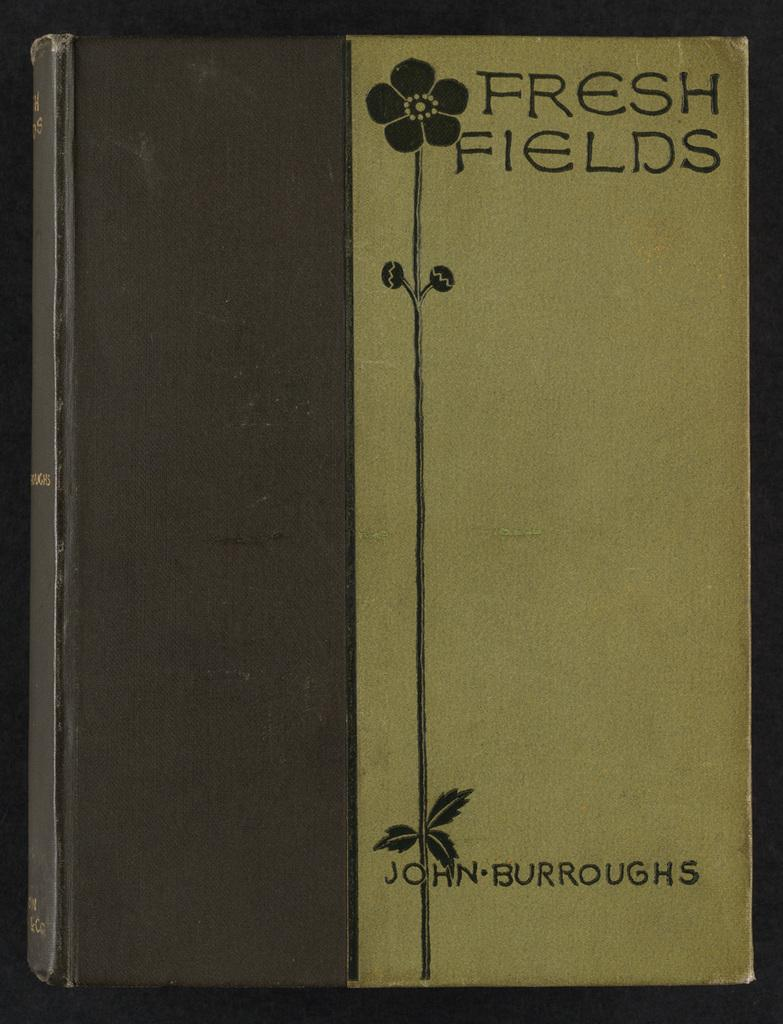Provide a one-sentence caption for the provided image. A book cover has a flower and the author name John Burroughs on it. 